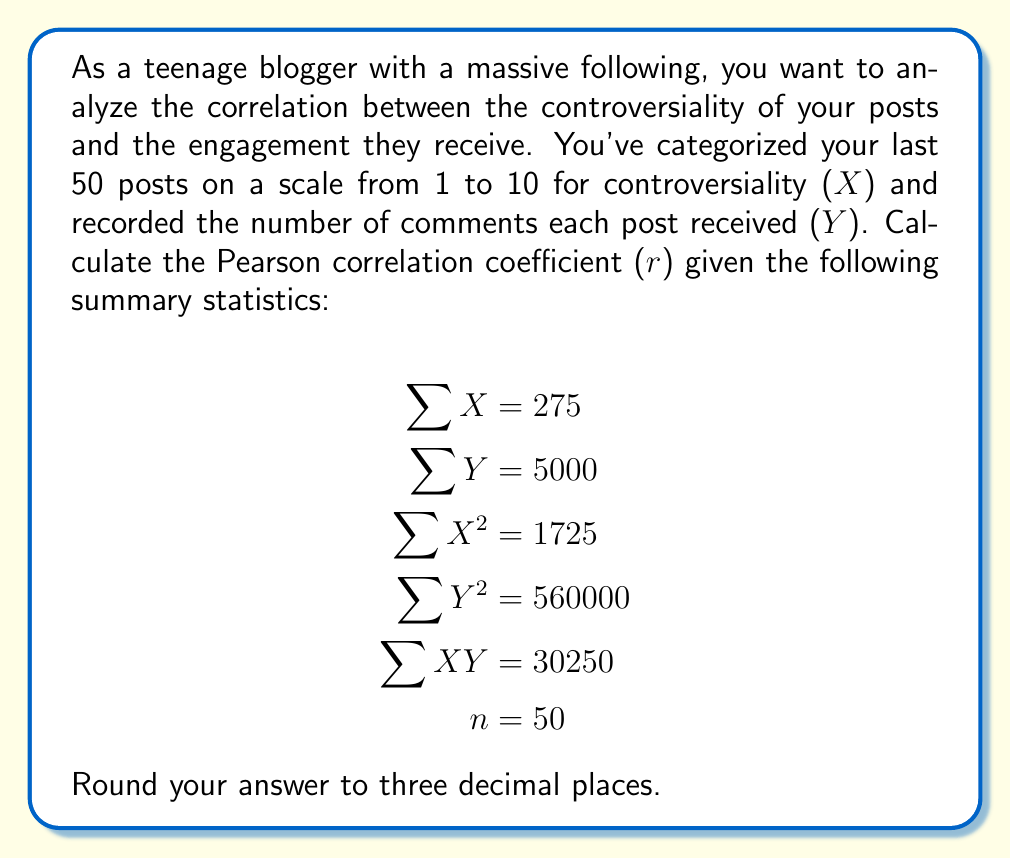Teach me how to tackle this problem. To calculate the Pearson correlation coefficient (r), we'll use the formula:

$$r = \frac{n\sum XY - \sum X \sum Y}{\sqrt{[n\sum X^2 - (\sum X)^2][n\sum Y^2 - (\sum Y)^2]}}$$

Let's substitute the given values:

$$r = \frac{50(30250) - (275)(5000)}{\sqrt{[50(1725) - (275)^2][50(560000) - (5000)^2]}}$$

Now, let's calculate step by step:

1. Numerator:
   $50(30250) - (275)(5000) = 1512500 - 1375000 = 137500$

2. Denominator:
   a) First part: $50(1725) - (275)^2 = 86250 - 75625 = 10625$
   b) Second part: $50(560000) - (5000)^2 = 28000000 - 25000000 = 3000000$
   c) Multiply: $10625 * 3000000 = 31875000000$
   d) Square root: $\sqrt{31875000000} = 178535.7$

3. Divide numerator by denominator:
   $\frac{137500}{178535.7} = 0.7701$

Rounding to three decimal places, we get 0.770.
Answer: 0.770 